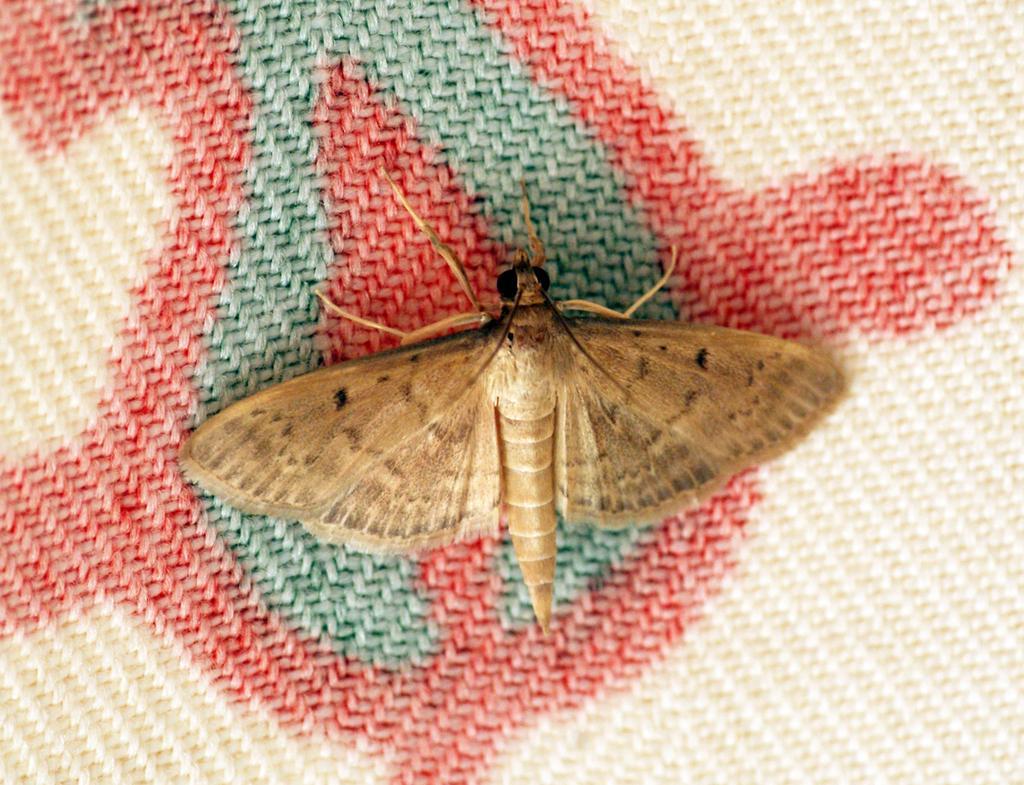Can you describe this image briefly? In this picture we can see a moth here, at the bottom there is a cloth. 